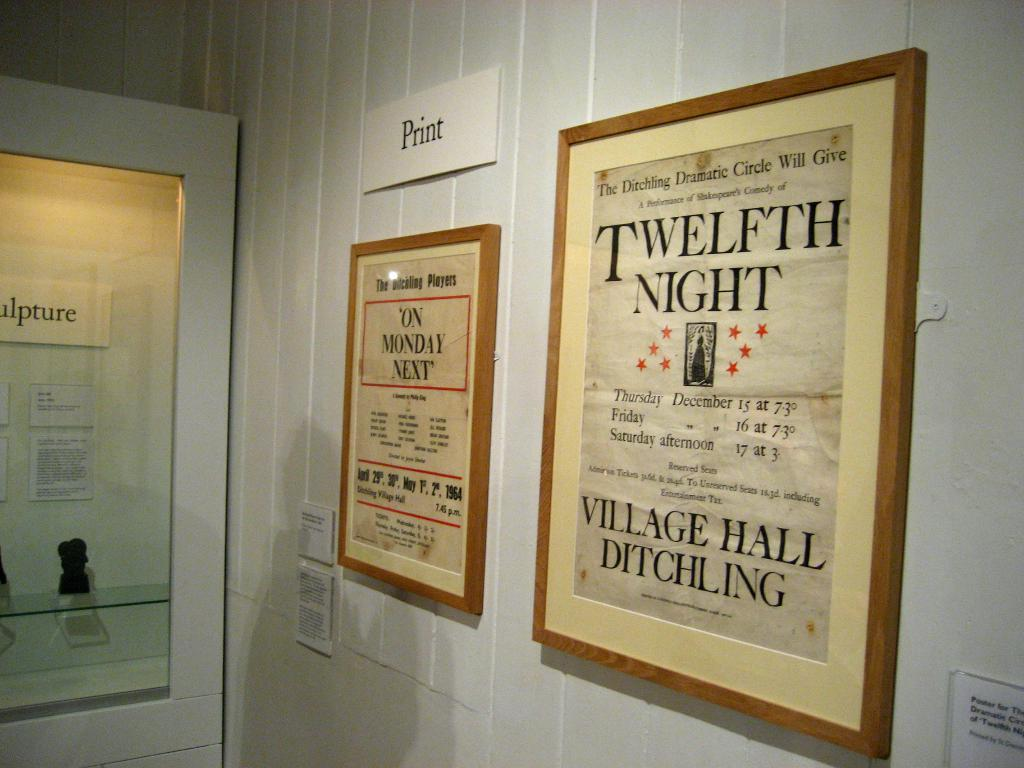<image>
Describe the image concisely. A framed printed poster for Twelfth Night hanging on a white wall. 